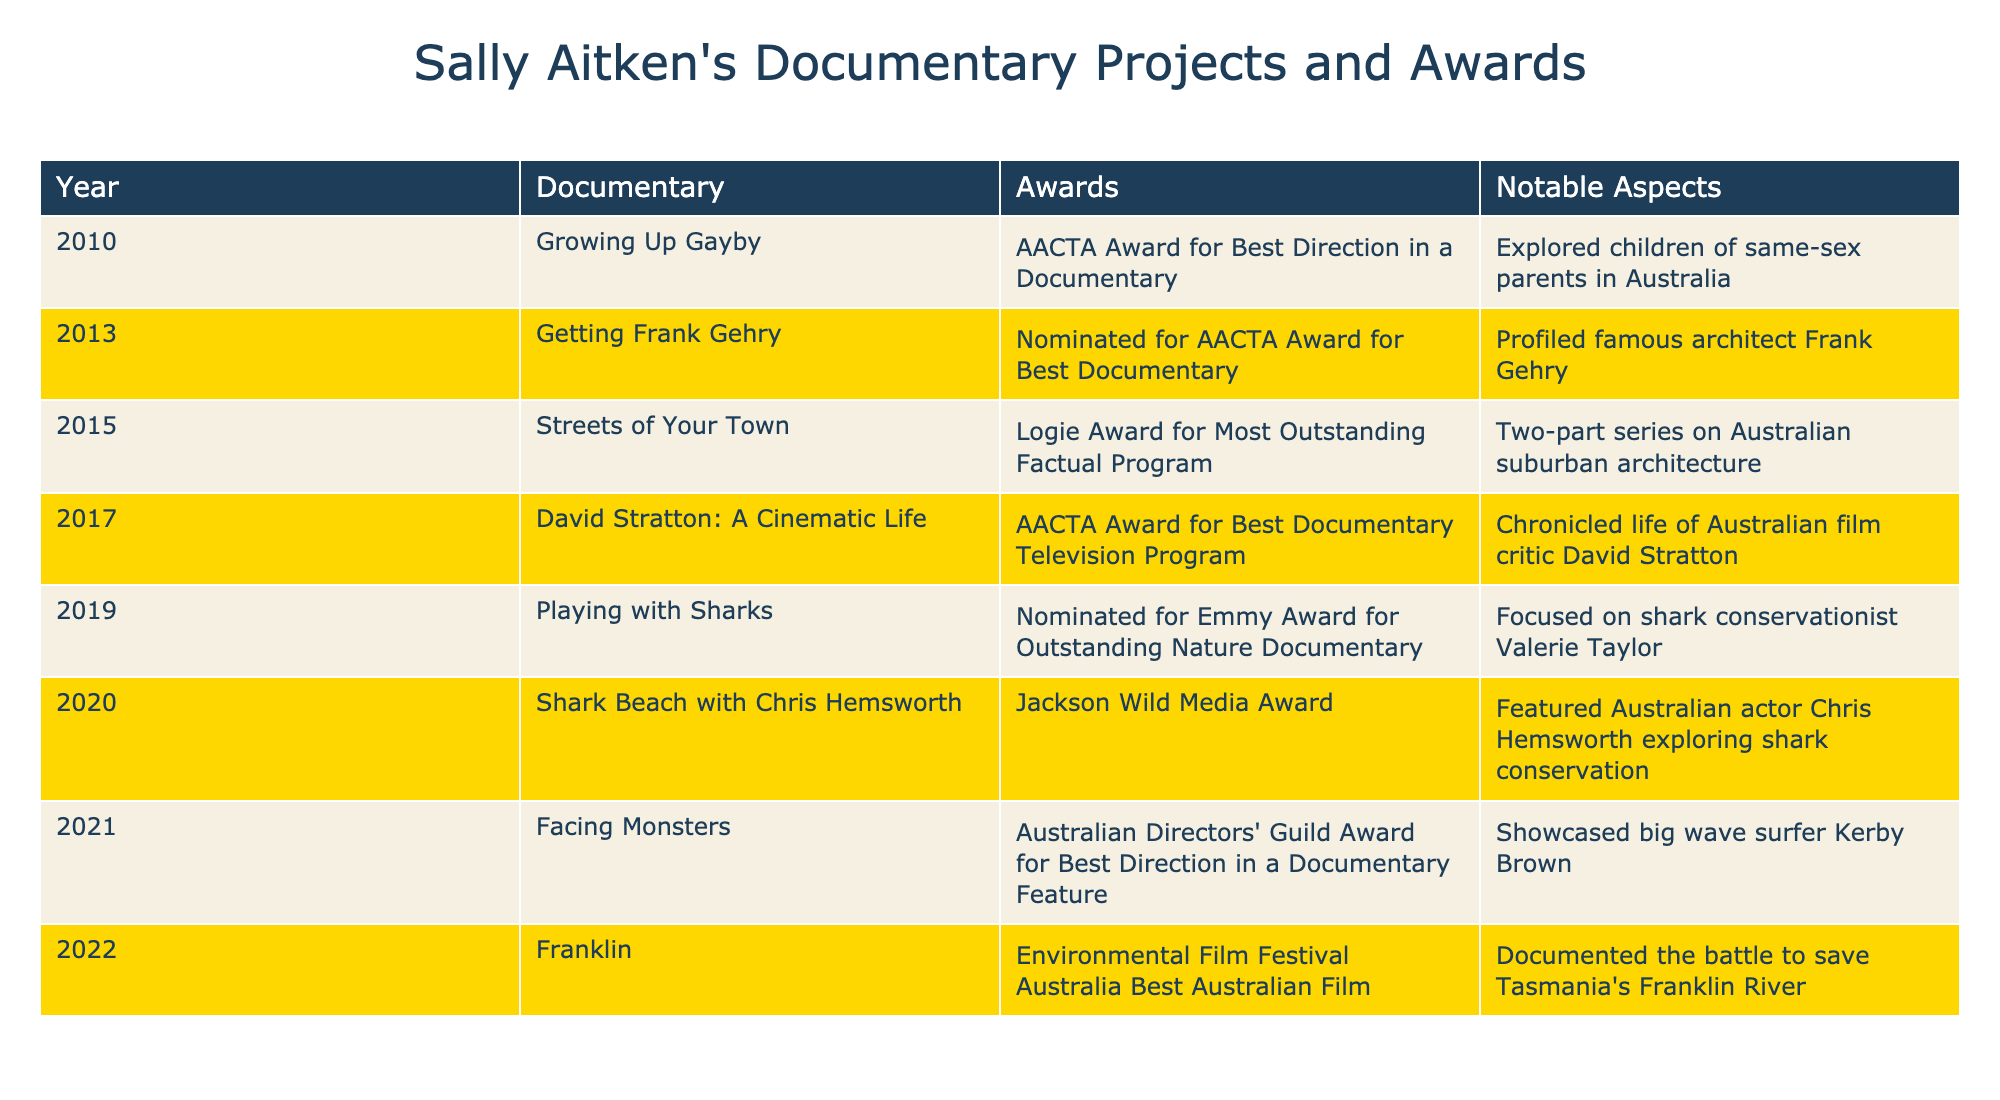What award did "Growing Up Gayby" win? The table states that "Growing Up Gayby" won the AACTA Award for Best Direction in a Documentary in 2010.
Answer: AACTA Award for Best Direction in a Documentary Which documentary was nominated for an Emmy Award? According to the table, "Playing with Sharks" was nominated for the Emmy Award for Outstanding Nature Documentary in 2019.
Answer: Playing with Sharks How many documentaries received awards in 2017? In 2017, the table indicates that only one documentary, "David Stratton: A Cinematic Life," received an AACTA Award for Best Documentary Television Program.
Answer: 1 What is the notable aspect of "Franklin"? The table describes the notable aspect of "Franklin" as documenting the battle to save Tasmania's Franklin River.
Answer: Documented the battle to save Tasmania's Franklin River Which documentary has the same award status as "Getting Frank Gehry"? "Getting Frank Gehry" is nominated for an AACTA Award for Best Documentary; this status matches that of "Playing with Sharks," which is also nominated for an award in a different category.
Answer: Playing with Sharks What is the total number of projects listed in the table? There are 8 entries in the table, each corresponding to a documentary project. This can be counted directly from the list.
Answer: 8 Which award was won for "Streets of Your Town"? The table states that "Streets of Your Town" won the Logie Award for Most Outstanding Factual Program in 2015.
Answer: Logie Award for Most Outstanding Factual Program Was "Shark Beach with Chris Hemsworth" recognized for its conservation theme? Yes, the table notes that "Shark Beach with Chris Hemsworth" received the Jackson Wild Media Award, which aligns with its theme of shark conservation.
Answer: Yes What was the only documentary that won an award in 2020, and what was the award? The only documentary that won an award in 2020 is "Shark Beach with Chris Hemsworth," which received the Jackson Wild Media Award.
Answer: Shark Beach with Chris Hemsworth, Jackson Wild Media Award How many documentaries focus on environmental issues? There are two documentaries related to environmental issues: "Franklin" and "Playing with Sharks," which both emphasize conservation themes.
Answer: 2 